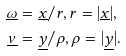<formula> <loc_0><loc_0><loc_500><loc_500>\underline { \omega } & = \underline { x } / r , r = | \underline { x } | , \\ \underline { \nu } & = \underline { y } / \rho , \rho = | \underline { y } | .</formula> 